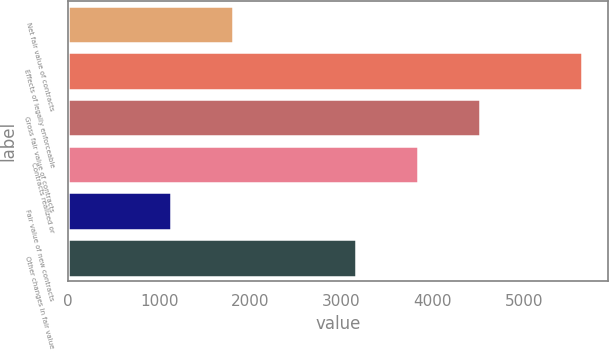Convert chart to OTSL. <chart><loc_0><loc_0><loc_500><loc_500><bar_chart><fcel>Net fair value of contracts<fcel>Effects of legally enforceable<fcel>Gross fair value of contracts<fcel>Contracts realized or<fcel>Fair value of new contracts<fcel>Other changes in fair value<nl><fcel>1805.8<fcel>5636<fcel>4521<fcel>3842.2<fcel>1127<fcel>3163.4<nl></chart> 